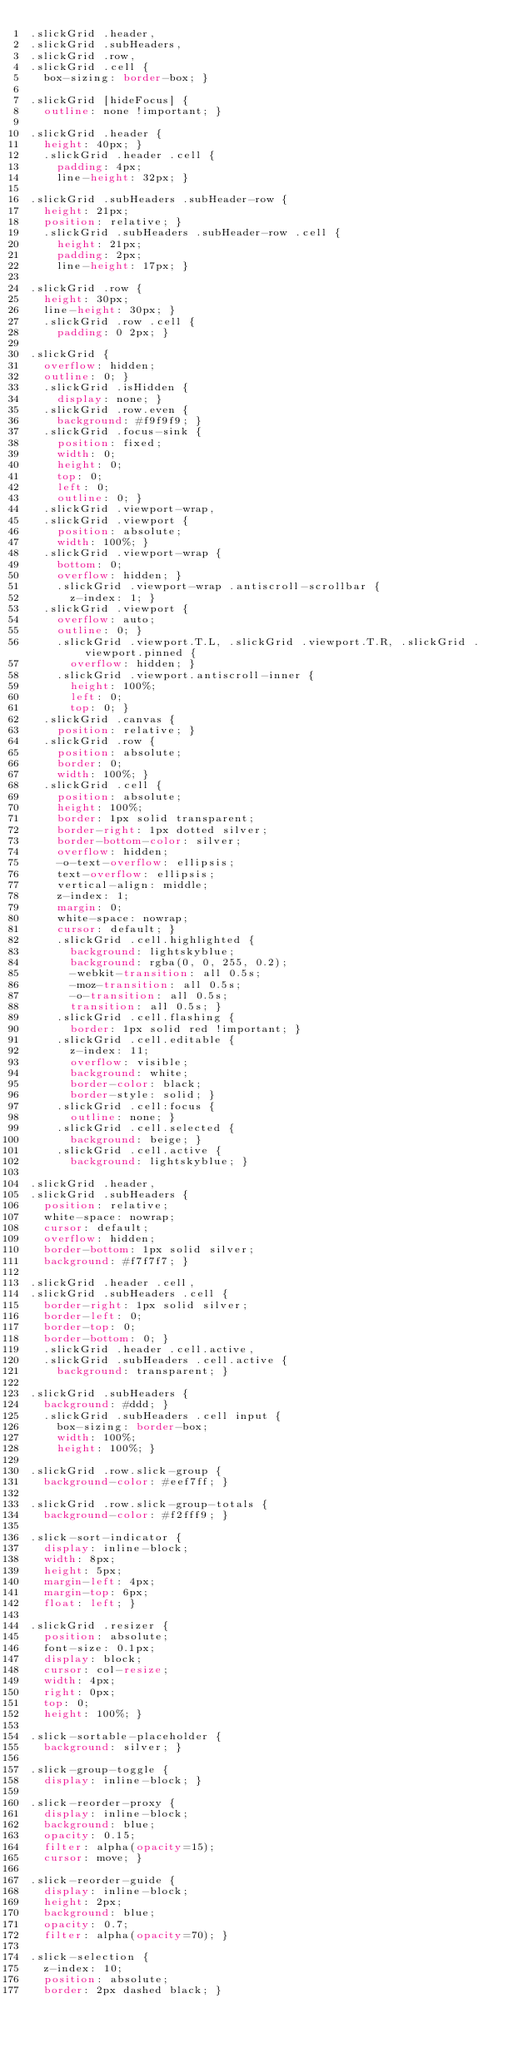<code> <loc_0><loc_0><loc_500><loc_500><_CSS_>.slickGrid .header,
.slickGrid .subHeaders,
.slickGrid .row,
.slickGrid .cell {
  box-sizing: border-box; }

.slickGrid [hideFocus] {
  outline: none !important; }

.slickGrid .header {
  height: 40px; }
  .slickGrid .header .cell {
    padding: 4px;
    line-height: 32px; }

.slickGrid .subHeaders .subHeader-row {
  height: 21px;
  position: relative; }
  .slickGrid .subHeaders .subHeader-row .cell {
    height: 21px;
    padding: 2px;
    line-height: 17px; }

.slickGrid .row {
  height: 30px;
  line-height: 30px; }
  .slickGrid .row .cell {
    padding: 0 2px; }

.slickGrid {
  overflow: hidden;
  outline: 0; }
  .slickGrid .isHidden {
    display: none; }
  .slickGrid .row.even {
    background: #f9f9f9; }
  .slickGrid .focus-sink {
    position: fixed;
    width: 0;
    height: 0;
    top: 0;
    left: 0;
    outline: 0; }
  .slickGrid .viewport-wrap,
  .slickGrid .viewport {
    position: absolute;
    width: 100%; }
  .slickGrid .viewport-wrap {
    bottom: 0;
    overflow: hidden; }
    .slickGrid .viewport-wrap .antiscroll-scrollbar {
      z-index: 1; }
  .slickGrid .viewport {
    overflow: auto;
    outline: 0; }
    .slickGrid .viewport.T.L, .slickGrid .viewport.T.R, .slickGrid .viewport.pinned {
      overflow: hidden; }
    .slickGrid .viewport.antiscroll-inner {
      height: 100%;
      left: 0;
      top: 0; }
  .slickGrid .canvas {
    position: relative; }
  .slickGrid .row {
    position: absolute;
    border: 0;
    width: 100%; }
  .slickGrid .cell {
    position: absolute;
    height: 100%;
    border: 1px solid transparent;
    border-right: 1px dotted silver;
    border-bottom-color: silver;
    overflow: hidden;
    -o-text-overflow: ellipsis;
    text-overflow: ellipsis;
    vertical-align: middle;
    z-index: 1;
    margin: 0;
    white-space: nowrap;
    cursor: default; }
    .slickGrid .cell.highlighted {
      background: lightskyblue;
      background: rgba(0, 0, 255, 0.2);
      -webkit-transition: all 0.5s;
      -moz-transition: all 0.5s;
      -o-transition: all 0.5s;
      transition: all 0.5s; }
    .slickGrid .cell.flashing {
      border: 1px solid red !important; }
    .slickGrid .cell.editable {
      z-index: 11;
      overflow: visible;
      background: white;
      border-color: black;
      border-style: solid; }
    .slickGrid .cell:focus {
      outline: none; }
    .slickGrid .cell.selected {
      background: beige; }
    .slickGrid .cell.active {
      background: lightskyblue; }

.slickGrid .header,
.slickGrid .subHeaders {
  position: relative;
  white-space: nowrap;
  cursor: default;
  overflow: hidden;
  border-bottom: 1px solid silver;
  background: #f7f7f7; }

.slickGrid .header .cell,
.slickGrid .subHeaders .cell {
  border-right: 1px solid silver;
  border-left: 0;
  border-top: 0;
  border-bottom: 0; }
  .slickGrid .header .cell.active,
  .slickGrid .subHeaders .cell.active {
    background: transparent; }

.slickGrid .subHeaders {
  background: #ddd; }
  .slickGrid .subHeaders .cell input {
    box-sizing: border-box;
    width: 100%;
    height: 100%; }

.slickGrid .row.slick-group {
  background-color: #eef7ff; }

.slickGrid .row.slick-group-totals {
  background-color: #f2fff9; }

.slick-sort-indicator {
  display: inline-block;
  width: 8px;
  height: 5px;
  margin-left: 4px;
  margin-top: 6px;
  float: left; }

.slickGrid .resizer {
  position: absolute;
  font-size: 0.1px;
  display: block;
  cursor: col-resize;
  width: 4px;
  right: 0px;
  top: 0;
  height: 100%; }

.slick-sortable-placeholder {
  background: silver; }

.slick-group-toggle {
  display: inline-block; }

.slick-reorder-proxy {
  display: inline-block;
  background: blue;
  opacity: 0.15;
  filter: alpha(opacity=15);
  cursor: move; }

.slick-reorder-guide {
  display: inline-block;
  height: 2px;
  background: blue;
  opacity: 0.7;
  filter: alpha(opacity=70); }

.slick-selection {
  z-index: 10;
  position: absolute;
  border: 2px dashed black; }
</code> 